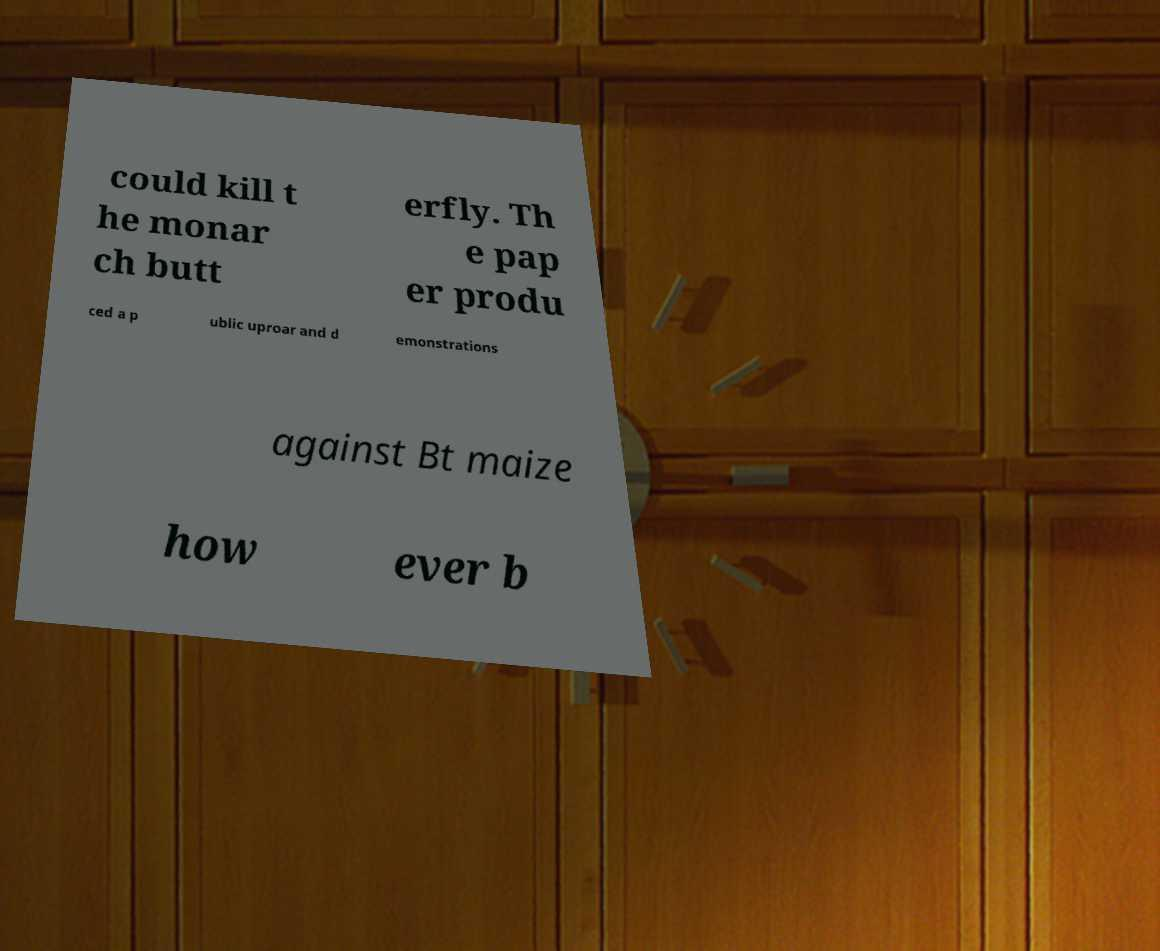For documentation purposes, I need the text within this image transcribed. Could you provide that? could kill t he monar ch butt erfly. Th e pap er produ ced a p ublic uproar and d emonstrations against Bt maize how ever b 